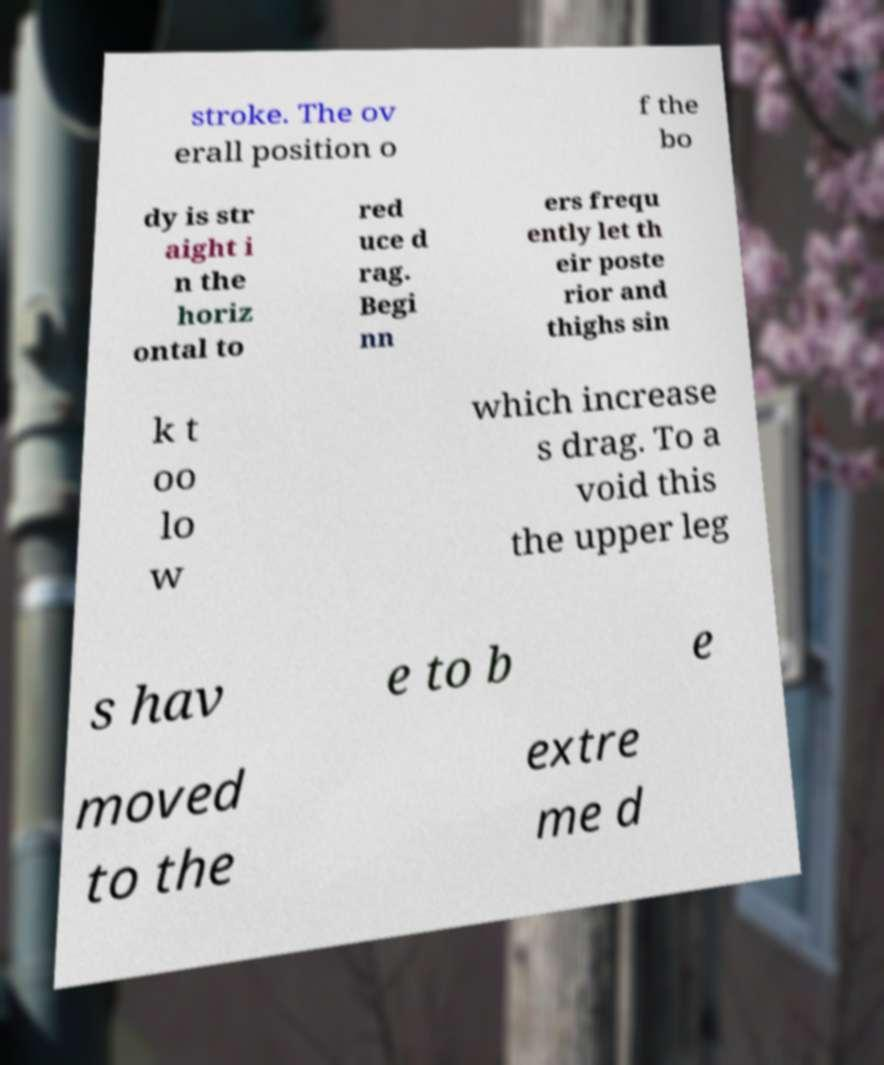What messages or text are displayed in this image? I need them in a readable, typed format. stroke. The ov erall position o f the bo dy is str aight i n the horiz ontal to red uce d rag. Begi nn ers frequ ently let th eir poste rior and thighs sin k t oo lo w which increase s drag. To a void this the upper leg s hav e to b e moved to the extre me d 